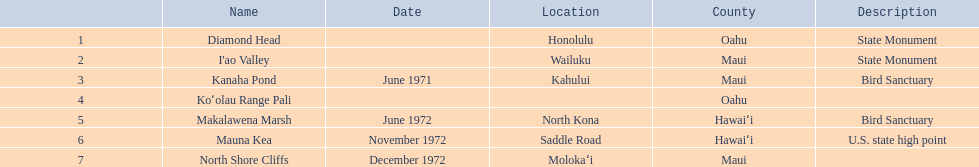What are the various monument titles? Diamond Head, I'ao Valley, Kanaha Pond, Koʻolau Range Pali, Makalawena Marsh, Mauna Kea, North Shore Cliffs. Which of these is situated in the county hawai`i? Makalawena Marsh, Mauna Kea. Which of these is not mauna kea? Makalawena Marsh. 